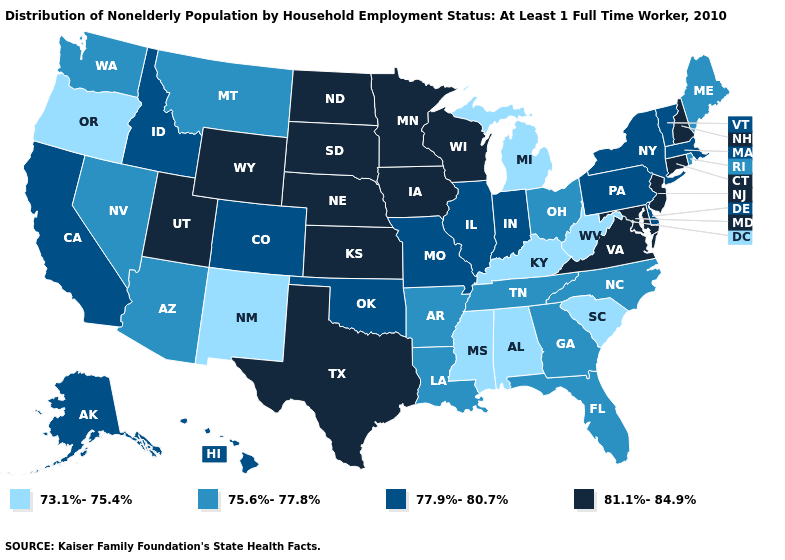What is the value of Arizona?
Give a very brief answer. 75.6%-77.8%. Name the states that have a value in the range 73.1%-75.4%?
Give a very brief answer. Alabama, Kentucky, Michigan, Mississippi, New Mexico, Oregon, South Carolina, West Virginia. What is the value of Delaware?
Be succinct. 77.9%-80.7%. Does Alabama have the same value as Wisconsin?
Concise answer only. No. Is the legend a continuous bar?
Keep it brief. No. Does Oregon have the lowest value in the West?
Answer briefly. Yes. Does New Mexico have the lowest value in the USA?
Answer briefly. Yes. What is the value of Idaho?
Write a very short answer. 77.9%-80.7%. Name the states that have a value in the range 73.1%-75.4%?
Answer briefly. Alabama, Kentucky, Michigan, Mississippi, New Mexico, Oregon, South Carolina, West Virginia. Name the states that have a value in the range 81.1%-84.9%?
Concise answer only. Connecticut, Iowa, Kansas, Maryland, Minnesota, Nebraska, New Hampshire, New Jersey, North Dakota, South Dakota, Texas, Utah, Virginia, Wisconsin, Wyoming. What is the lowest value in states that border New Mexico?
Write a very short answer. 75.6%-77.8%. Among the states that border North Dakota , which have the highest value?
Short answer required. Minnesota, South Dakota. Which states have the lowest value in the MidWest?
Give a very brief answer. Michigan. What is the value of Maryland?
Answer briefly. 81.1%-84.9%. 